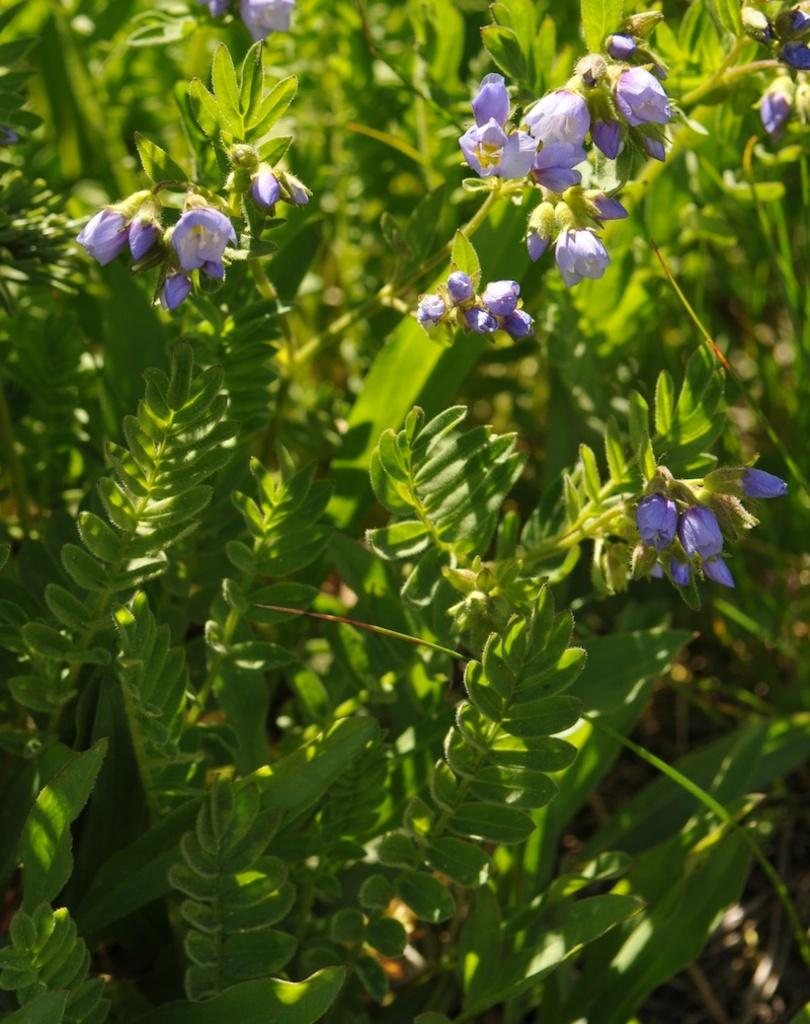What type of plant can be seen in the image? There is a flower plant in the image. What type of silk material is draped over the flower plant in the image? There is no silk material draped over the flower plant in the image; it is a simple representation of a flower plant. 